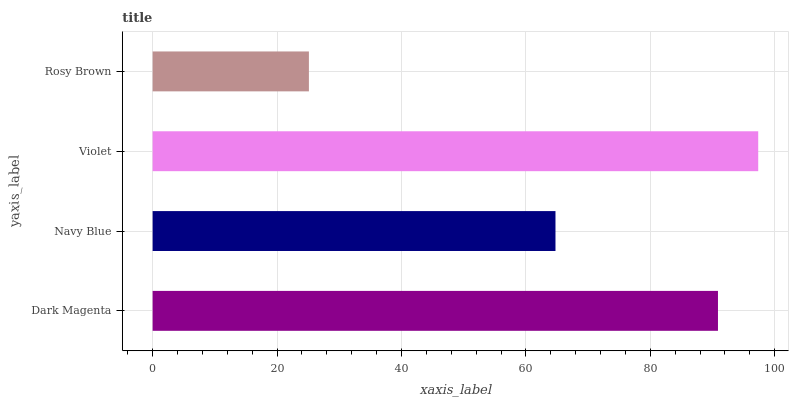Is Rosy Brown the minimum?
Answer yes or no. Yes. Is Violet the maximum?
Answer yes or no. Yes. Is Navy Blue the minimum?
Answer yes or no. No. Is Navy Blue the maximum?
Answer yes or no. No. Is Dark Magenta greater than Navy Blue?
Answer yes or no. Yes. Is Navy Blue less than Dark Magenta?
Answer yes or no. Yes. Is Navy Blue greater than Dark Magenta?
Answer yes or no. No. Is Dark Magenta less than Navy Blue?
Answer yes or no. No. Is Dark Magenta the high median?
Answer yes or no. Yes. Is Navy Blue the low median?
Answer yes or no. Yes. Is Violet the high median?
Answer yes or no. No. Is Violet the low median?
Answer yes or no. No. 